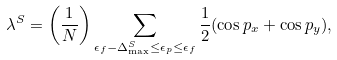Convert formula to latex. <formula><loc_0><loc_0><loc_500><loc_500>\lambda ^ { S } = \left ( \frac { 1 } { N } \right ) \sum _ { \epsilon _ { f } - \Delta ^ { S } _ { \max } \leq \epsilon _ { p } \leq \epsilon _ { f } } \frac { 1 } { 2 } ( \cos p _ { x } + \cos p _ { y } ) ,</formula> 